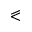<formula> <loc_0><loc_0><loc_500><loc_500>\ e q s l a n t l e s s</formula> 